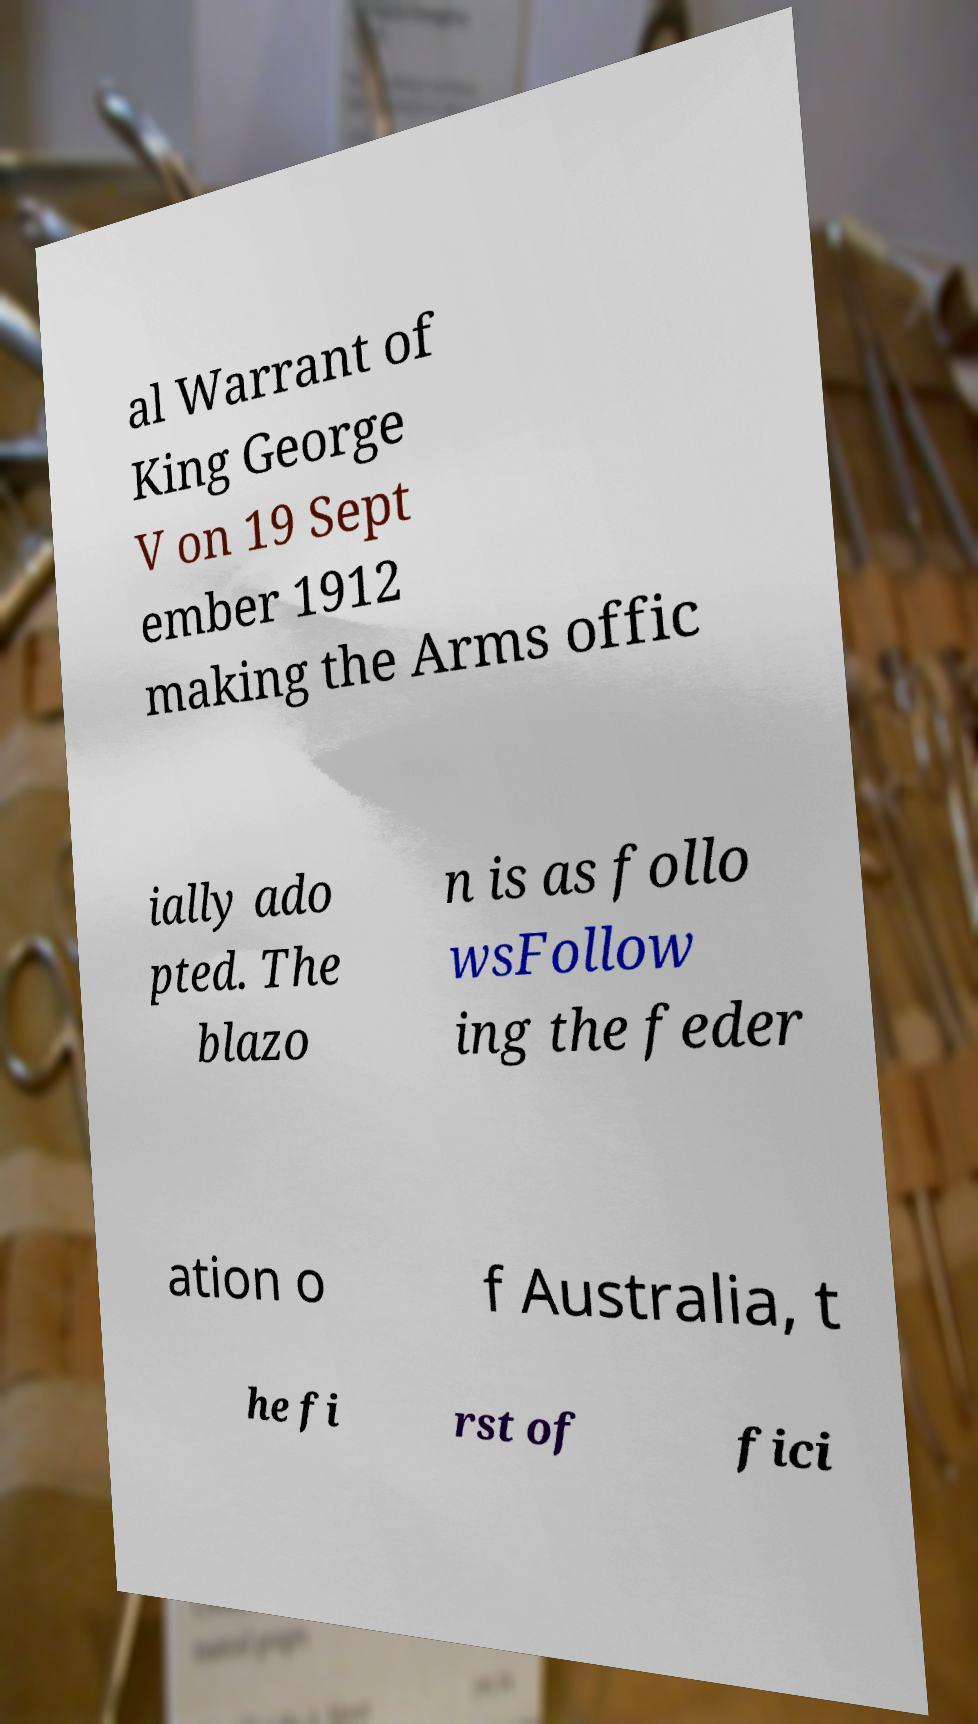There's text embedded in this image that I need extracted. Can you transcribe it verbatim? al Warrant of King George V on 19 Sept ember 1912 making the Arms offic ially ado pted. The blazo n is as follo wsFollow ing the feder ation o f Australia, t he fi rst of fici 